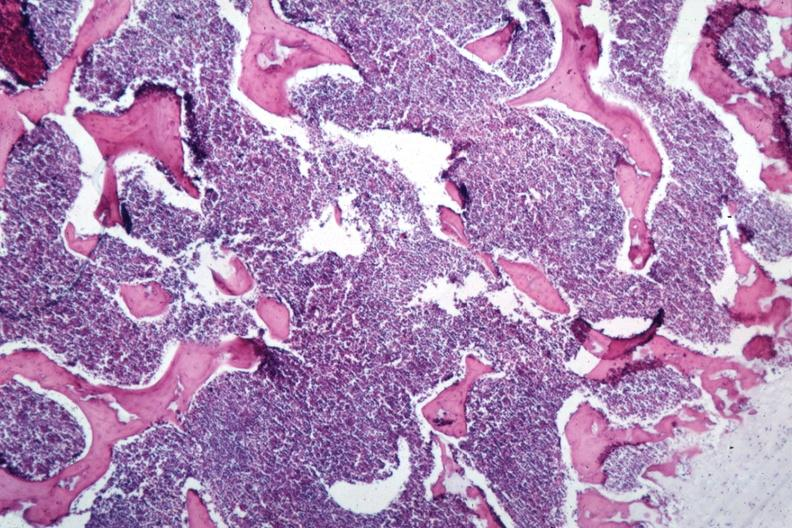s lymphoblastic lymphoma present?
Answer the question using a single word or phrase. Yes 